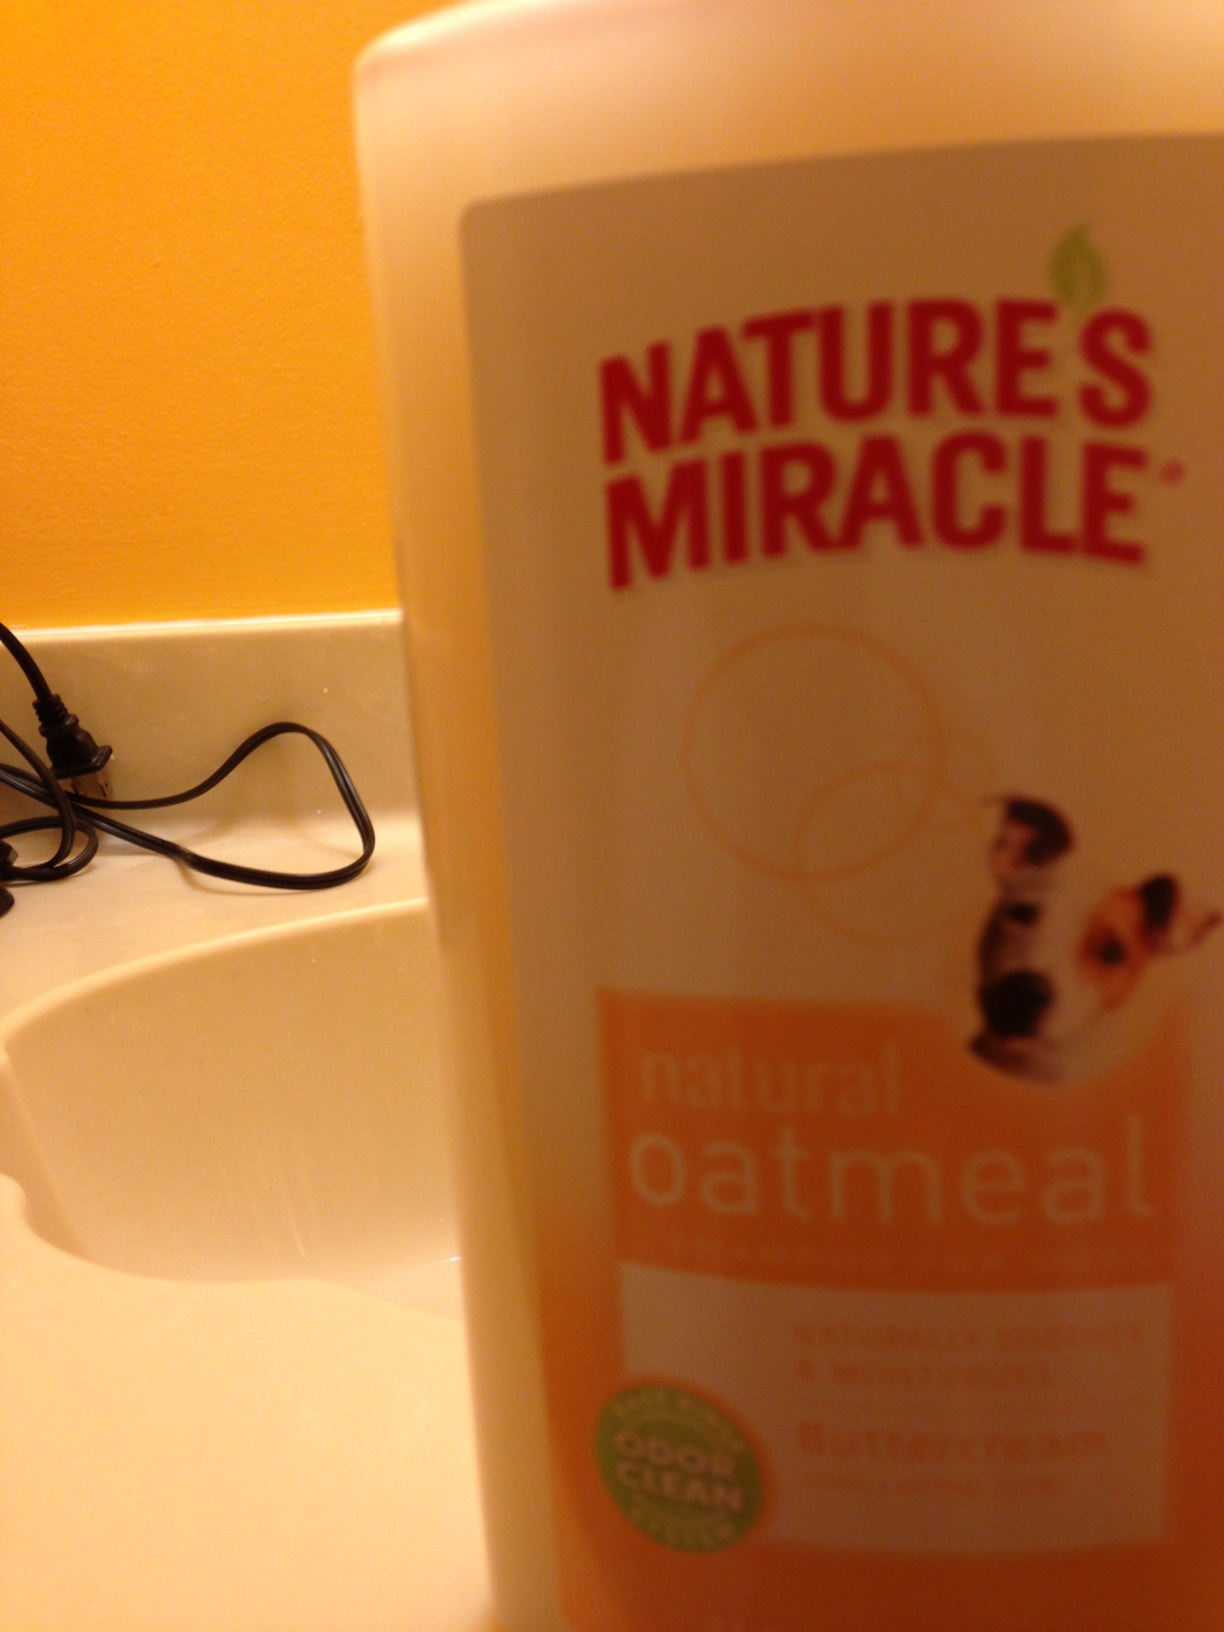What would be the ideal usage for a product like this? This type of shampoo is ideal for regular grooming routines, particularly for dogs who may suffer from dry, itchy skin or are prone to unpleasant smells. It's gentle yet effective, which means it can be used routinely for baths to keep your dog's coat clean, soothe any skin discomfort, and combat odor buildup without harsh chemicals. 